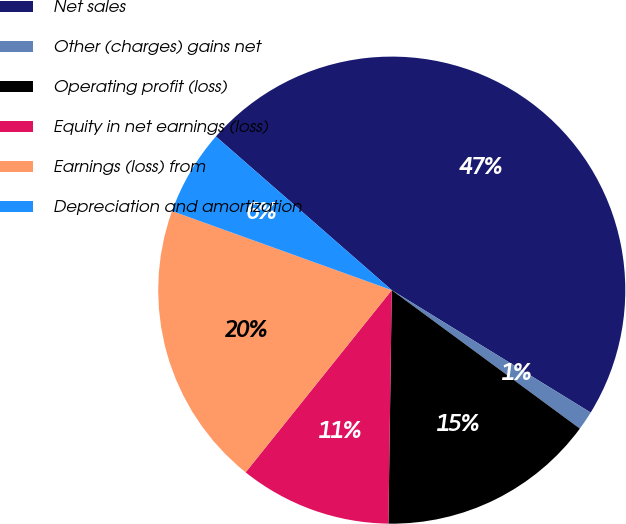Convert chart. <chart><loc_0><loc_0><loc_500><loc_500><pie_chart><fcel>Net sales<fcel>Other (charges) gains net<fcel>Operating profit (loss)<fcel>Equity in net earnings (loss)<fcel>Earnings (loss) from<fcel>Depreciation and amortization<nl><fcel>47.35%<fcel>1.32%<fcel>15.13%<fcel>10.53%<fcel>19.74%<fcel>5.93%<nl></chart> 